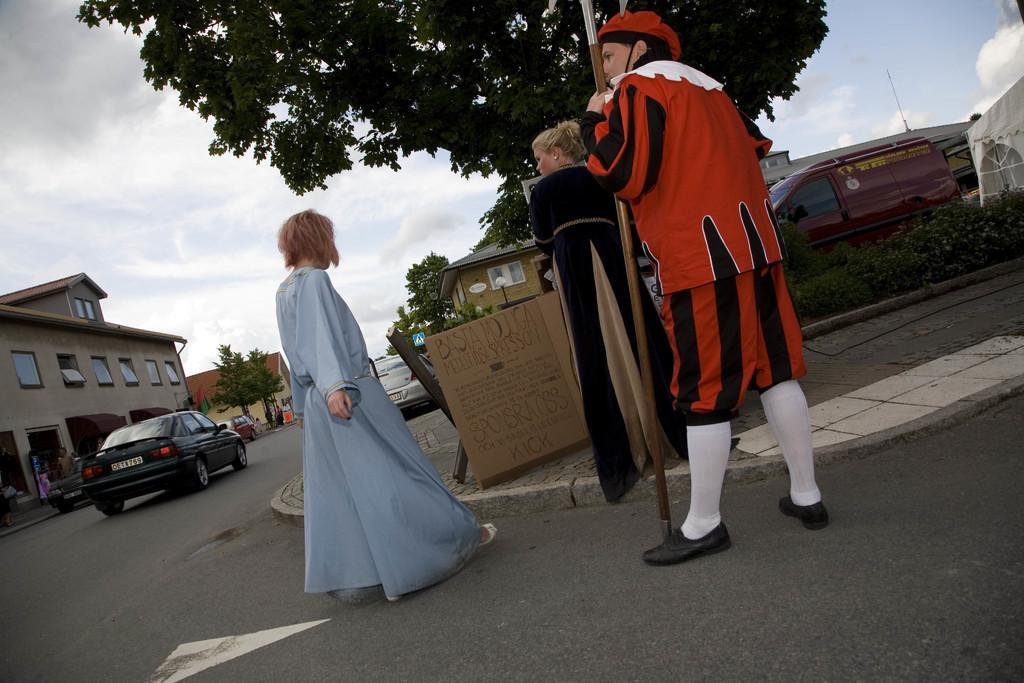Could you give a brief overview of what you see in this image? In this picture there is a woman who is wearing a black dress. Behind her there is a man who is wearing a red dress and black shoes and he is holding a stick. In front of him there is a girl who is wearing grey dress and shoes. On the left there is a black color car which is running on the road. Beside that I can see the buildings, trees and other vehicles. At the top I can see the tree. In the top right corner I can see the sky and clouds. On the right I can see the van which is parked near to the tent and plants. 